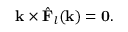Convert formula to latex. <formula><loc_0><loc_0><loc_500><loc_500>k \times { \hat { F } } _ { l } ( k ) = 0 .</formula> 